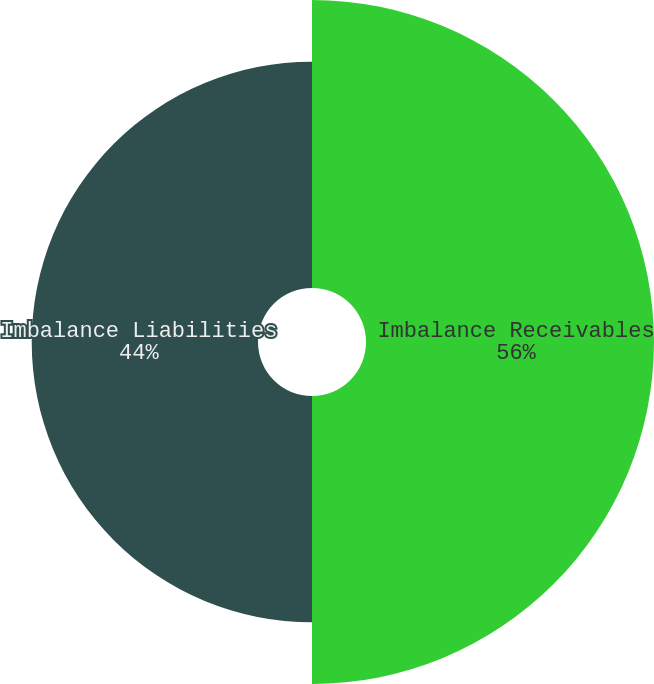<chart> <loc_0><loc_0><loc_500><loc_500><pie_chart><fcel>Imbalance Receivables<fcel>Imbalance Liabilities<nl><fcel>56.0%<fcel>44.0%<nl></chart> 